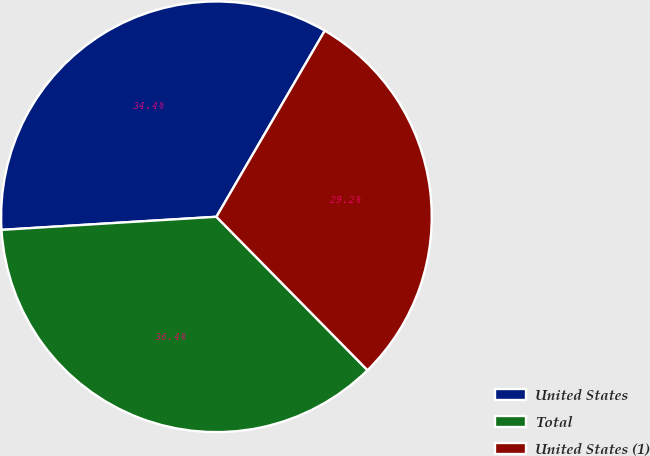Convert chart. <chart><loc_0><loc_0><loc_500><loc_500><pie_chart><fcel>United States<fcel>Total<fcel>United States (1)<nl><fcel>34.36%<fcel>36.41%<fcel>29.23%<nl></chart> 